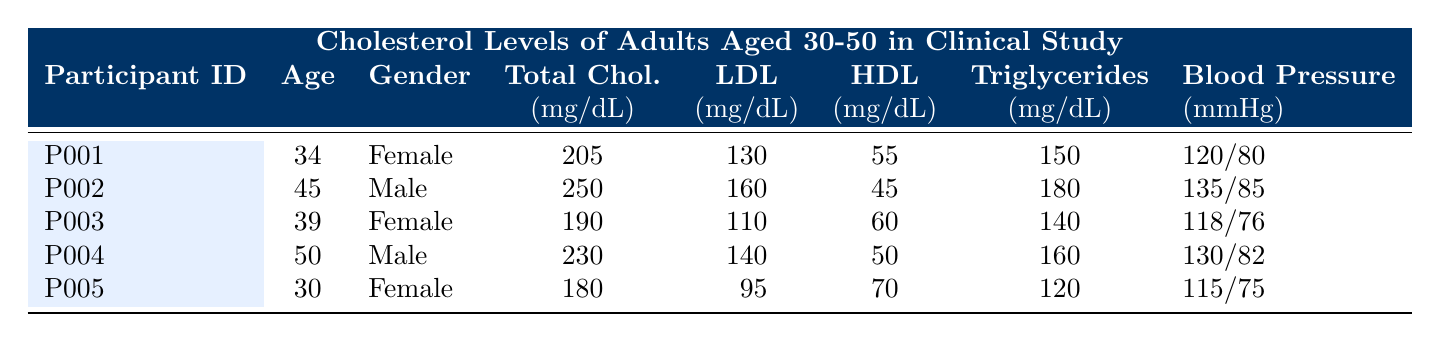What is the total cholesterol level of participant P002? The table clearly lists the total cholesterol level for participant P002 under the "Total Chol." column as 250 mg/dL.
Answer: 250 mg/dL What is the HDL cholesterol level for the oldest participant? The oldest participant is P004, who is 50 years old. Looking in the "HDL" column for P004, the HDL level is 50 mg/dL.
Answer: 50 mg/dL How many participants have LDL levels greater than 130 mg/dL? We can see from the "LDL" column that P002 (160), P004 (140), and P001 (130) have LDL levels over 130 mg/dL, hence three participants exceed this level.
Answer: 3 What is the average age of all participants? The ages of all participants are 34, 45, 39, 50, and 30. First, we find the sum: (34 + 45 + 39 + 50 + 30) = 198. There are 5 participants, so dividing gives us an average age of 198/5 = 39.6 years.
Answer: 39.6 years Is participant P005 male? The gender of participant P005 is listed as Female in the "Gender" column, therefore it is false that P005 is male.
Answer: No What is the triglyceride level difference between participant P002 and participant P003? Participant P002 has a triglyceride level of 180 mg/dL, while P003 has 140 mg/dL. The difference is calculated as 180 - 140 = 40 mg/dL.
Answer: 40 mg/dL What is the blood pressure reading of participant P001? According to the table, participant P001 has a blood pressure reading listed as 120/80 under the "Blood Pressure" column.
Answer: 120/80 Which participant has the highest total cholesterol level? Reviewing the "Total Chol." column, participant P002 has the highest cholesterol level at 250 mg/dL, which is greater than all other participants.
Answer: P002 